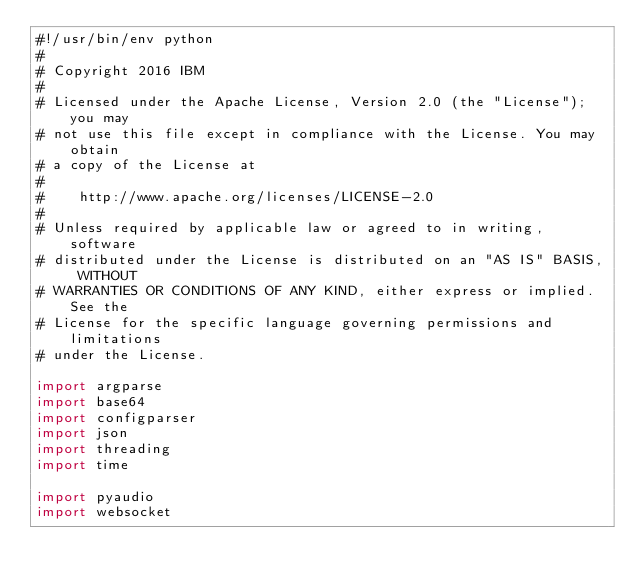<code> <loc_0><loc_0><loc_500><loc_500><_Python_>#!/usr/bin/env python
#
# Copyright 2016 IBM
#
# Licensed under the Apache License, Version 2.0 (the "License"); you may
# not use this file except in compliance with the License. You may obtain
# a copy of the License at
#
#    http://www.apache.org/licenses/LICENSE-2.0
#
# Unless required by applicable law or agreed to in writing, software
# distributed under the License is distributed on an "AS IS" BASIS, WITHOUT
# WARRANTIES OR CONDITIONS OF ANY KIND, either express or implied. See the
# License for the specific language governing permissions and limitations
# under the License.

import argparse
import base64
import configparser
import json
import threading
import time

import pyaudio
import websocket</code> 